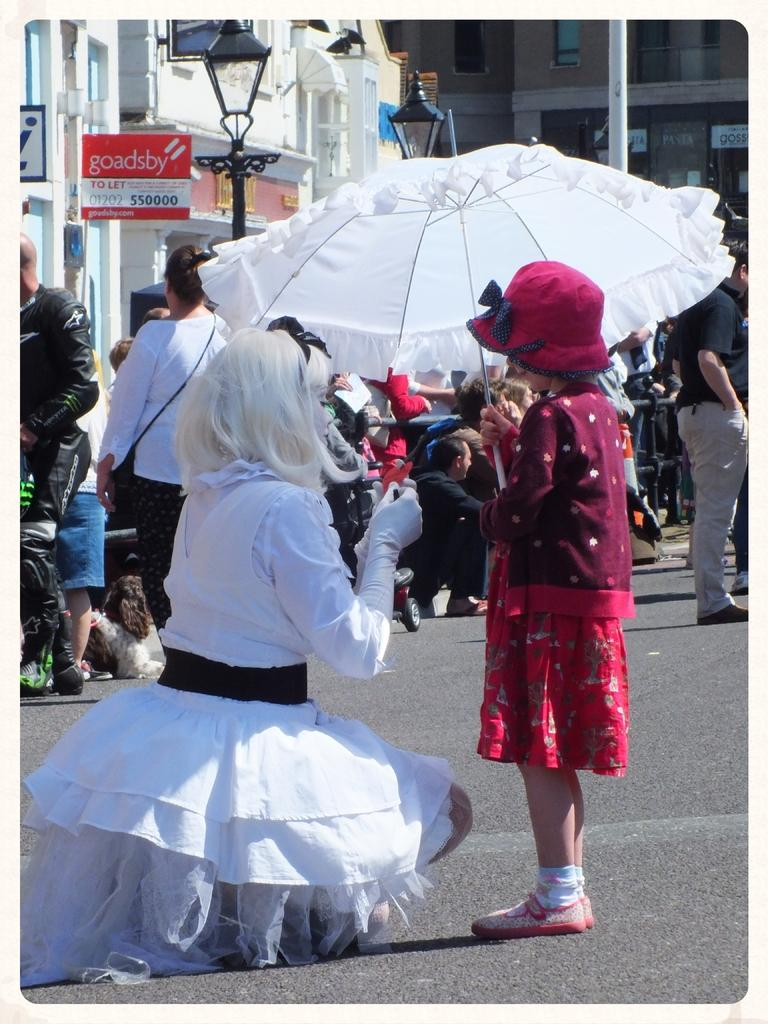What is the girl in the foreground of the image holding? The girl in the foreground of the image is holding an umbrella. What is the woman in the foreground of the image doing? The woman in the foreground of the image is kneeling down on the road. Can you describe the background of the image? The background of the image includes persons, poles, and at least one building. How many people are visible in the image? There are at least two people visible in the image: the girl and the woman in the foreground. What type of acoustics can be heard in the park in the image? There is no park present in the image, and therefore no acoustics can be heard. 